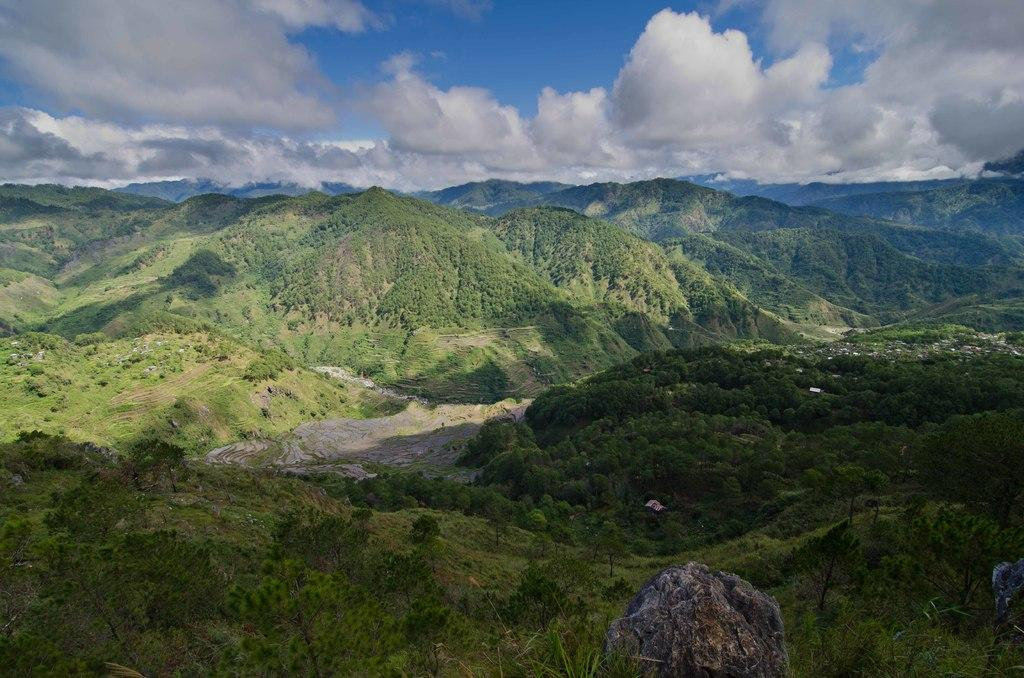What is located in the foreground of the image? There are rocks in the foreground of the image. What can be seen in the background of the image? There are trees, mountains, and the sky visible in the background of the image. Can you describe the natural environment in the image? The image features a landscape with rocks, trees, mountains, and the sky. What type of pain can be seen on the faces of the rocks in the image? There is no indication of pain on the rocks in the image, as rocks are inanimate objects and do not have facial expressions or emotions. 